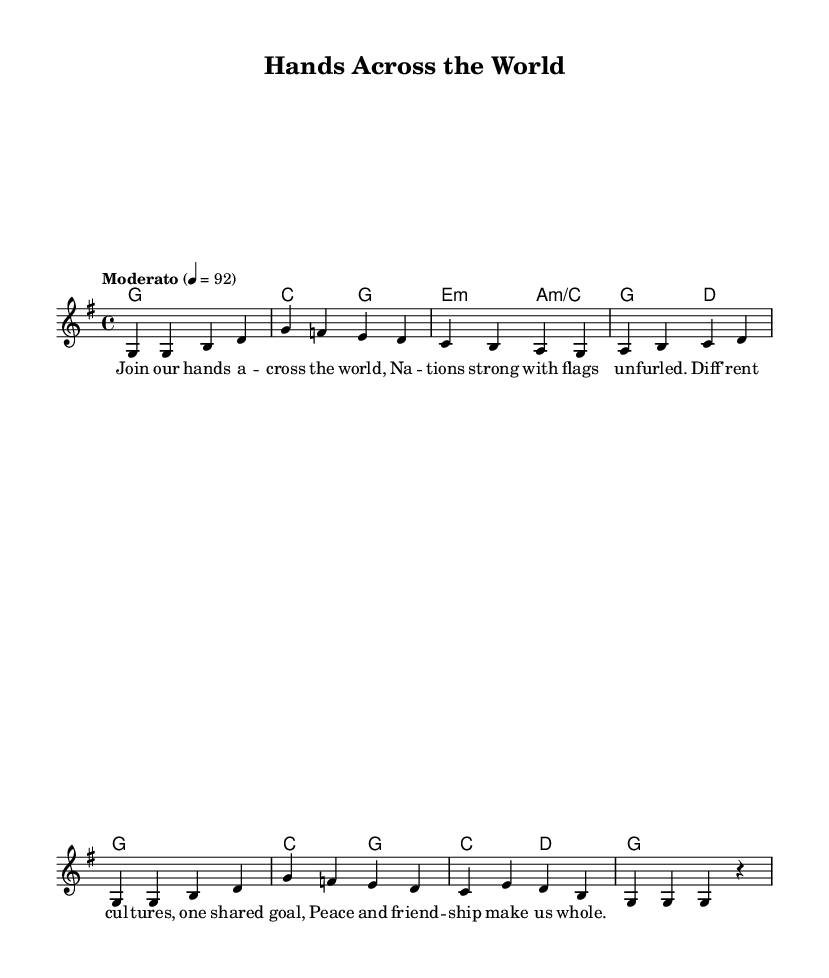What is the key signature of this music? The key signature is G major, which has one sharp (F#). This can be identified by looking at the key signature indicated at the beginning of the sheet music.
Answer: G major What is the time signature of this music? The time signature is 4/4, which means there are four beats per measure. This is shown prominently at the beginning of the sheet music.
Answer: 4/4 What is the tempo marking for this piece? The tempo marking is "Moderato," indicating a moderate pace. Tempo markings provide guidance on how fast the piece should be played, located above the staff in the sheet music.
Answer: Moderato How many measures are there in the melody? There are eight measures in the melody, which are counted as the number of groups of beats divided by bar lines in the melodic line.
Answer: 8 What is the overall theme expressed in the lyrics? The overall theme expressed in the lyrics is global unity and cooperation. By analyzing the words, we see a focus on solidarity among nations and shared goals for peace.
Answer: Global unity and cooperation What chord is played in the second measure? The chord in the second measure is C major, which can be identified by looking at the chord names written above the staff in the harmonies.
Answer: C major How does the structure of this traditional folk song promote its message? The structure of the song combines simple melodies with repetitive lyrics, making it easy to remember and sing along, which is effective in conveying the message of unity and cooperation among diverse cultures.
Answer: Repetitive lyrics and simple melodies 